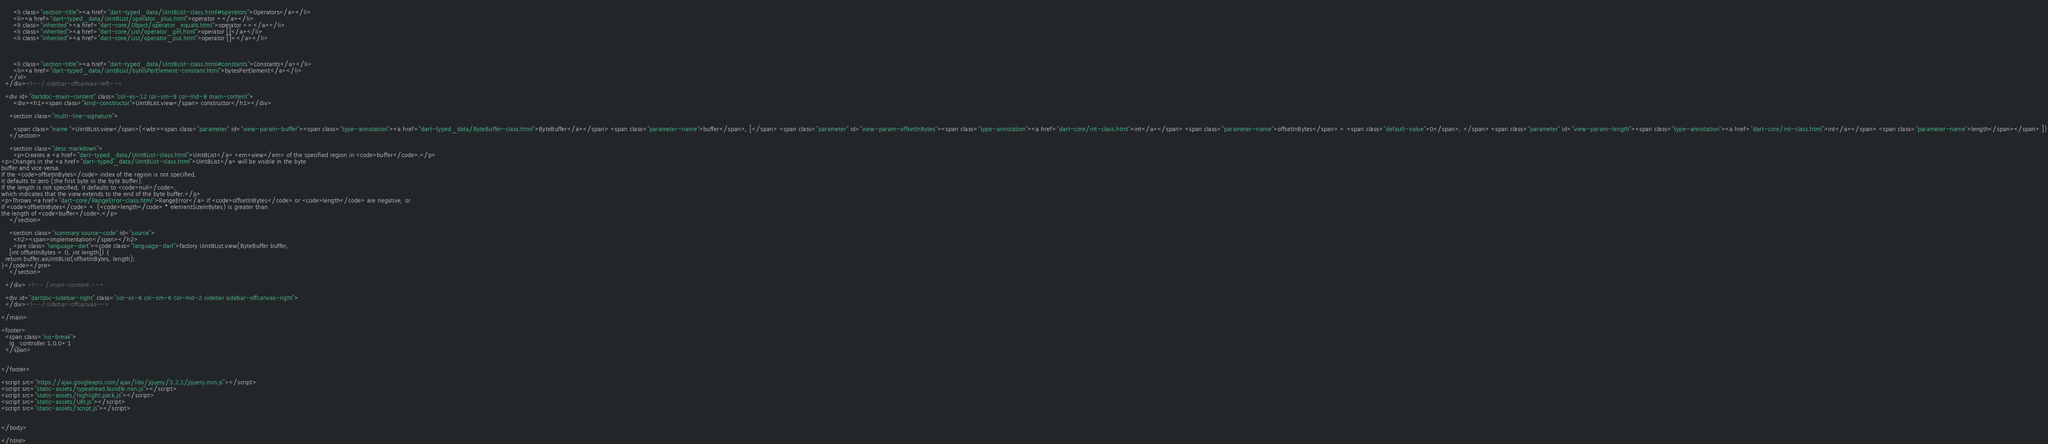Convert code to text. <code><loc_0><loc_0><loc_500><loc_500><_HTML_>    
      <li class="section-title"><a href="dart-typed_data/Uint8List-class.html#operators">Operators</a></li>
      <li><a href="dart-typed_data/Uint8List/operator_plus.html">operator +</a></li>
      <li class="inherited"><a href="dart-core/Object/operator_equals.html">operator ==</a></li>
      <li class="inherited"><a href="dart-core/List/operator_get.html">operator []</a></li>
      <li class="inherited"><a href="dart-core/List/operator_put.html">operator []=</a></li>
    
    
    
      <li class="section-title"><a href="dart-typed_data/Uint8List-class.html#constants">Constants</a></li>
      <li><a href="dart-typed_data/Uint8List/bytesPerElement-constant.html">bytesPerElement</a></li>
    </ol>
  </div><!--/.sidebar-offcanvas-left-->

  <div id="dartdoc-main-content" class="col-xs-12 col-sm-9 col-md-8 main-content">
      <div><h1><span class="kind-constructor">Uint8List.view</span> constructor</h1></div>

    <section class="multi-line-signature">
      
      <span class="name ">Uint8List.view</span>(<wbr><span class="parameter" id="view-param-buffer"><span class="type-annotation"><a href="dart-typed_data/ByteBuffer-class.html">ByteBuffer</a></span> <span class="parameter-name">buffer</span>, [</span> <span class="parameter" id="view-param-offsetInBytes"><span class="type-annotation"><a href="dart-core/int-class.html">int</a></span> <span class="parameter-name">offsetInBytes</span> = <span class="default-value">0</span>, </span> <span class="parameter" id="view-param-length"><span class="type-annotation"><a href="dart-core/int-class.html">int</a></span> <span class="parameter-name">length</span></span> ])
    </section>

    <section class="desc markdown">
      <p>Creates a <a href="dart-typed_data/Uint8List-class.html">Uint8List</a> <em>view</em> of the specified region in <code>buffer</code>.</p>
<p>Changes in the <a href="dart-typed_data/Uint8List-class.html">Uint8List</a> will be visible in the byte
buffer and vice versa.
If the <code>offsetInBytes</code> index of the region is not specified,
it defaults to zero (the first byte in the byte buffer).
If the length is not specified, it defaults to <code>null</code>,
which indicates that the view extends to the end of the byte buffer.</p>
<p>Throws <a href="dart-core/RangeError-class.html">RangeError</a> if <code>offsetInBytes</code> or <code>length</code> are negative, or
if <code>offsetInBytes</code> + (<code>length</code> * elementSizeInBytes) is greater than
the length of <code>buffer</code>.</p>
    </section>
    
    <section class="summary source-code" id="source">
      <h2><span>Implementation</span></h2>
      <pre class="language-dart"><code class="language-dart">factory Uint8List.view(ByteBuffer buffer,
    [int offsetInBytes = 0, int length]) {
  return buffer.asUint8List(offsetInBytes, length);
}</code></pre>
    </section>

  </div> <!-- /.main-content -->

  <div id="dartdoc-sidebar-right" class="col-xs-6 col-sm-6 col-md-2 sidebar sidebar-offcanvas-right">
  </div><!--/.sidebar-offcanvas-->

</main>

<footer>
  <span class="no-break">
    lg_controller 1.0.0+1
  </span>

  
</footer>

<script src="https://ajax.googleapis.com/ajax/libs/jquery/3.2.1/jquery.min.js"></script>
<script src="static-assets/typeahead.bundle.min.js"></script>
<script src="static-assets/highlight.pack.js"></script>
<script src="static-assets/URI.js"></script>
<script src="static-assets/script.js"></script>


</body>

</html>
</code> 